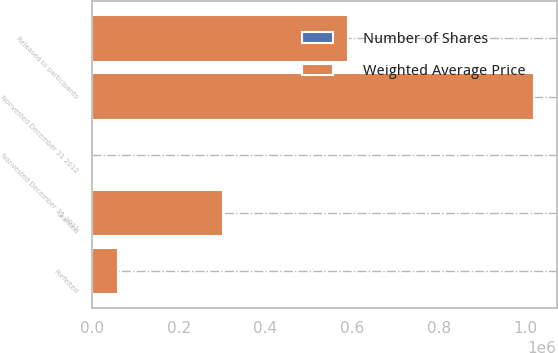<chart> <loc_0><loc_0><loc_500><loc_500><stacked_bar_chart><ecel><fcel>Nonvested December 31 2011<fcel>Granted<fcel>Released to participants<fcel>Forfeited<fcel>Nonvested December 31 2012<nl><fcel>Weighted Average Price<fcel>36.65<fcel>300950<fcel>589333<fcel>59691<fcel>1.0206e+06<nl><fcel>Number of Shares<fcel>20.79<fcel>36.65<fcel>17.13<fcel>27.07<fcel>27.21<nl></chart> 